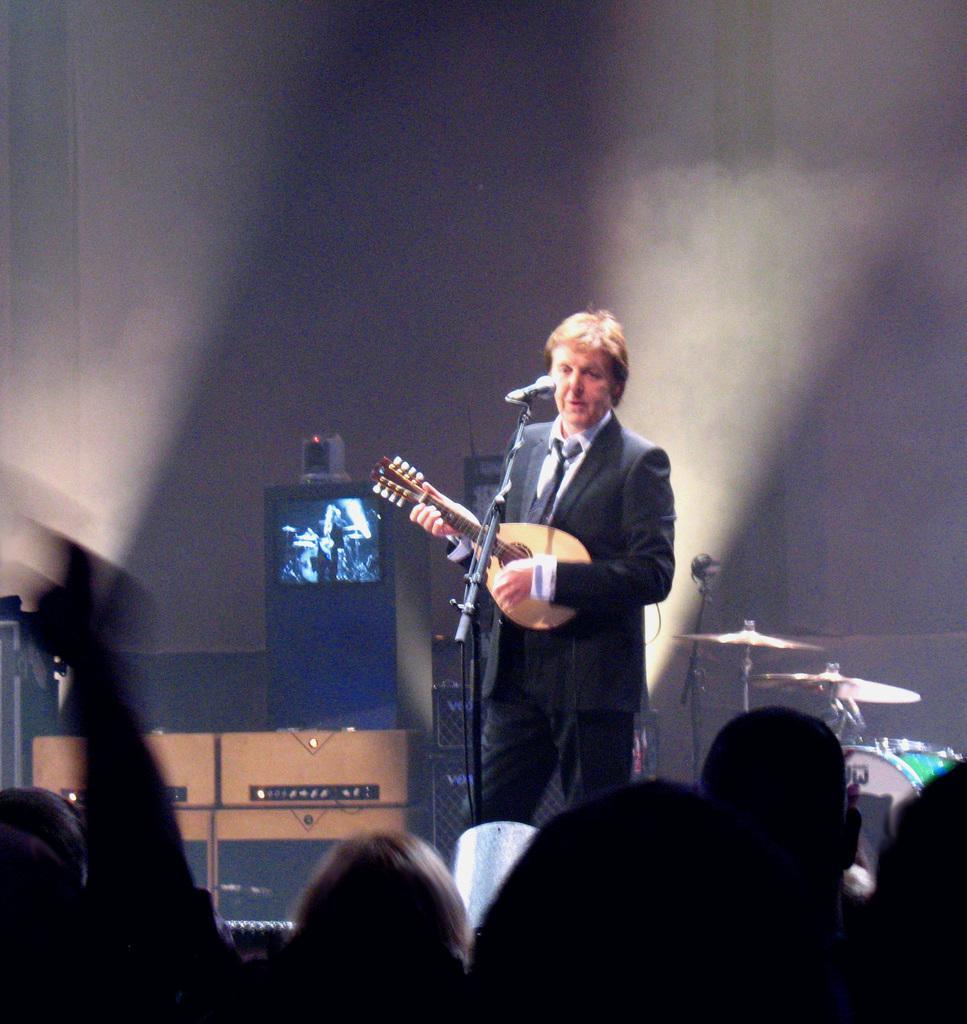Describe this image in one or two sentences. In this image I can see a man is playing guitar in front of a microphone on a stage. I can also see there are few people and other musical instruments. 